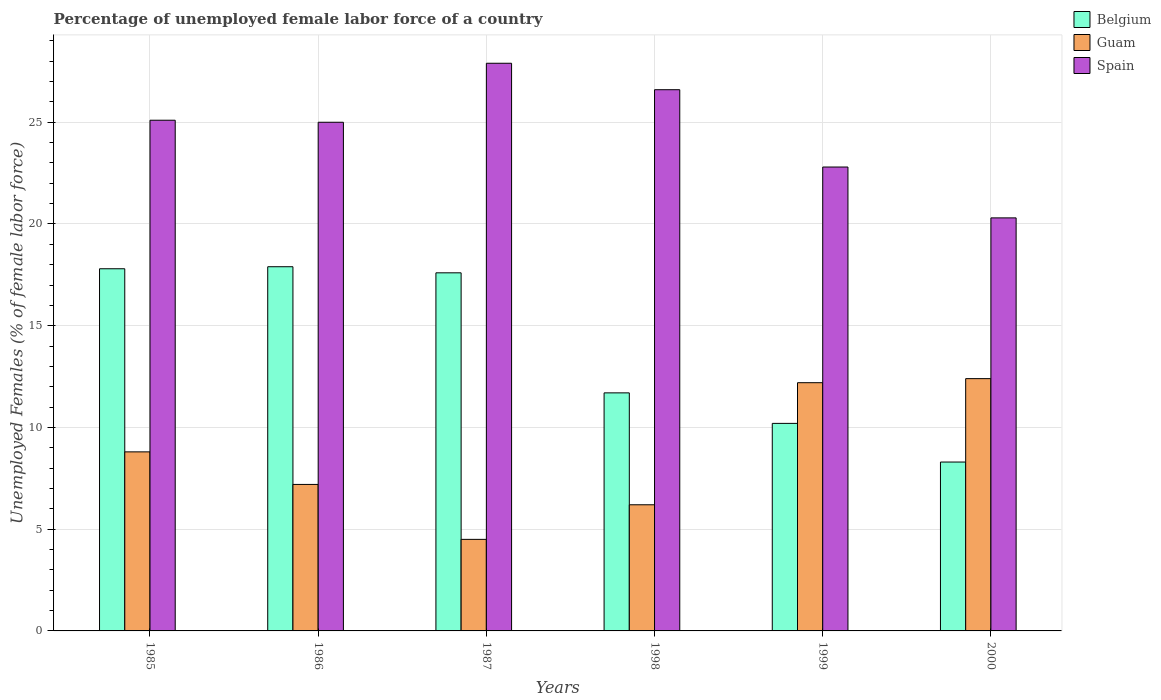How many different coloured bars are there?
Your answer should be compact. 3. What is the percentage of unemployed female labor force in Belgium in 1986?
Offer a very short reply. 17.9. Across all years, what is the maximum percentage of unemployed female labor force in Guam?
Your answer should be compact. 12.4. Across all years, what is the minimum percentage of unemployed female labor force in Belgium?
Give a very brief answer. 8.3. In which year was the percentage of unemployed female labor force in Belgium maximum?
Your answer should be very brief. 1986. What is the total percentage of unemployed female labor force in Belgium in the graph?
Provide a short and direct response. 83.5. What is the difference between the percentage of unemployed female labor force in Belgium in 1998 and that in 2000?
Provide a short and direct response. 3.4. What is the difference between the percentage of unemployed female labor force in Belgium in 1999 and the percentage of unemployed female labor force in Spain in 1985?
Offer a very short reply. -14.9. What is the average percentage of unemployed female labor force in Guam per year?
Offer a very short reply. 8.55. In the year 2000, what is the difference between the percentage of unemployed female labor force in Belgium and percentage of unemployed female labor force in Spain?
Your answer should be very brief. -12. In how many years, is the percentage of unemployed female labor force in Guam greater than 14 %?
Make the answer very short. 0. What is the ratio of the percentage of unemployed female labor force in Guam in 1987 to that in 1999?
Your response must be concise. 0.37. What is the difference between the highest and the second highest percentage of unemployed female labor force in Guam?
Your answer should be very brief. 0.2. What is the difference between the highest and the lowest percentage of unemployed female labor force in Spain?
Ensure brevity in your answer.  7.6. What does the 3rd bar from the left in 1987 represents?
Offer a terse response. Spain. Is it the case that in every year, the sum of the percentage of unemployed female labor force in Guam and percentage of unemployed female labor force in Belgium is greater than the percentage of unemployed female labor force in Spain?
Make the answer very short. No. How many bars are there?
Your answer should be compact. 18. Are all the bars in the graph horizontal?
Make the answer very short. No. How many years are there in the graph?
Make the answer very short. 6. What is the difference between two consecutive major ticks on the Y-axis?
Ensure brevity in your answer.  5. Are the values on the major ticks of Y-axis written in scientific E-notation?
Offer a very short reply. No. Does the graph contain any zero values?
Provide a short and direct response. No. Does the graph contain grids?
Offer a very short reply. Yes. How are the legend labels stacked?
Keep it short and to the point. Vertical. What is the title of the graph?
Keep it short and to the point. Percentage of unemployed female labor force of a country. Does "Nigeria" appear as one of the legend labels in the graph?
Your answer should be very brief. No. What is the label or title of the Y-axis?
Give a very brief answer. Unemployed Females (% of female labor force). What is the Unemployed Females (% of female labor force) of Belgium in 1985?
Keep it short and to the point. 17.8. What is the Unemployed Females (% of female labor force) in Guam in 1985?
Your answer should be very brief. 8.8. What is the Unemployed Females (% of female labor force) in Spain in 1985?
Your answer should be very brief. 25.1. What is the Unemployed Females (% of female labor force) of Belgium in 1986?
Give a very brief answer. 17.9. What is the Unemployed Females (% of female labor force) in Guam in 1986?
Ensure brevity in your answer.  7.2. What is the Unemployed Females (% of female labor force) of Spain in 1986?
Your answer should be compact. 25. What is the Unemployed Females (% of female labor force) of Belgium in 1987?
Keep it short and to the point. 17.6. What is the Unemployed Females (% of female labor force) of Spain in 1987?
Your response must be concise. 27.9. What is the Unemployed Females (% of female labor force) of Belgium in 1998?
Offer a very short reply. 11.7. What is the Unemployed Females (% of female labor force) of Guam in 1998?
Give a very brief answer. 6.2. What is the Unemployed Females (% of female labor force) in Spain in 1998?
Provide a succinct answer. 26.6. What is the Unemployed Females (% of female labor force) in Belgium in 1999?
Provide a short and direct response. 10.2. What is the Unemployed Females (% of female labor force) of Guam in 1999?
Your answer should be compact. 12.2. What is the Unemployed Females (% of female labor force) in Spain in 1999?
Provide a short and direct response. 22.8. What is the Unemployed Females (% of female labor force) in Belgium in 2000?
Keep it short and to the point. 8.3. What is the Unemployed Females (% of female labor force) of Guam in 2000?
Keep it short and to the point. 12.4. What is the Unemployed Females (% of female labor force) of Spain in 2000?
Make the answer very short. 20.3. Across all years, what is the maximum Unemployed Females (% of female labor force) of Belgium?
Offer a terse response. 17.9. Across all years, what is the maximum Unemployed Females (% of female labor force) in Guam?
Offer a very short reply. 12.4. Across all years, what is the maximum Unemployed Females (% of female labor force) of Spain?
Make the answer very short. 27.9. Across all years, what is the minimum Unemployed Females (% of female labor force) in Belgium?
Give a very brief answer. 8.3. Across all years, what is the minimum Unemployed Females (% of female labor force) of Guam?
Give a very brief answer. 4.5. Across all years, what is the minimum Unemployed Females (% of female labor force) of Spain?
Ensure brevity in your answer.  20.3. What is the total Unemployed Females (% of female labor force) in Belgium in the graph?
Ensure brevity in your answer.  83.5. What is the total Unemployed Females (% of female labor force) of Guam in the graph?
Give a very brief answer. 51.3. What is the total Unemployed Females (% of female labor force) of Spain in the graph?
Provide a short and direct response. 147.7. What is the difference between the Unemployed Females (% of female labor force) of Belgium in 1985 and that in 1986?
Provide a short and direct response. -0.1. What is the difference between the Unemployed Females (% of female labor force) in Belgium in 1985 and that in 1998?
Give a very brief answer. 6.1. What is the difference between the Unemployed Females (% of female labor force) in Spain in 1985 and that in 1998?
Provide a succinct answer. -1.5. What is the difference between the Unemployed Females (% of female labor force) of Guam in 1985 and that in 1999?
Provide a succinct answer. -3.4. What is the difference between the Unemployed Females (% of female labor force) of Belgium in 1985 and that in 2000?
Offer a terse response. 9.5. What is the difference between the Unemployed Females (% of female labor force) of Guam in 1986 and that in 1987?
Provide a succinct answer. 2.7. What is the difference between the Unemployed Females (% of female labor force) in Guam in 1986 and that in 1998?
Offer a very short reply. 1. What is the difference between the Unemployed Females (% of female labor force) of Spain in 1986 and that in 1999?
Your answer should be very brief. 2.2. What is the difference between the Unemployed Females (% of female labor force) of Spain in 1986 and that in 2000?
Give a very brief answer. 4.7. What is the difference between the Unemployed Females (% of female labor force) in Spain in 1987 and that in 1998?
Provide a succinct answer. 1.3. What is the difference between the Unemployed Females (% of female labor force) of Belgium in 1987 and that in 1999?
Give a very brief answer. 7.4. What is the difference between the Unemployed Females (% of female labor force) in Spain in 1987 and that in 1999?
Offer a terse response. 5.1. What is the difference between the Unemployed Females (% of female labor force) in Belgium in 1987 and that in 2000?
Offer a very short reply. 9.3. What is the difference between the Unemployed Females (% of female labor force) of Spain in 1987 and that in 2000?
Give a very brief answer. 7.6. What is the difference between the Unemployed Females (% of female labor force) in Guam in 1998 and that in 1999?
Provide a succinct answer. -6. What is the difference between the Unemployed Females (% of female labor force) of Spain in 1998 and that in 1999?
Provide a succinct answer. 3.8. What is the difference between the Unemployed Females (% of female labor force) in Spain in 1998 and that in 2000?
Offer a very short reply. 6.3. What is the difference between the Unemployed Females (% of female labor force) of Belgium in 1999 and that in 2000?
Offer a very short reply. 1.9. What is the difference between the Unemployed Females (% of female labor force) of Belgium in 1985 and the Unemployed Females (% of female labor force) of Spain in 1986?
Give a very brief answer. -7.2. What is the difference between the Unemployed Females (% of female labor force) of Guam in 1985 and the Unemployed Females (% of female labor force) of Spain in 1986?
Give a very brief answer. -16.2. What is the difference between the Unemployed Females (% of female labor force) in Guam in 1985 and the Unemployed Females (% of female labor force) in Spain in 1987?
Provide a succinct answer. -19.1. What is the difference between the Unemployed Females (% of female labor force) of Belgium in 1985 and the Unemployed Females (% of female labor force) of Guam in 1998?
Offer a terse response. 11.6. What is the difference between the Unemployed Females (% of female labor force) in Belgium in 1985 and the Unemployed Females (% of female labor force) in Spain in 1998?
Your response must be concise. -8.8. What is the difference between the Unemployed Females (% of female labor force) in Guam in 1985 and the Unemployed Females (% of female labor force) in Spain in 1998?
Give a very brief answer. -17.8. What is the difference between the Unemployed Females (% of female labor force) in Belgium in 1985 and the Unemployed Females (% of female labor force) in Spain in 2000?
Offer a terse response. -2.5. What is the difference between the Unemployed Females (% of female labor force) of Guam in 1985 and the Unemployed Females (% of female labor force) of Spain in 2000?
Your response must be concise. -11.5. What is the difference between the Unemployed Females (% of female labor force) in Belgium in 1986 and the Unemployed Females (% of female labor force) in Guam in 1987?
Your response must be concise. 13.4. What is the difference between the Unemployed Females (% of female labor force) of Guam in 1986 and the Unemployed Females (% of female labor force) of Spain in 1987?
Provide a succinct answer. -20.7. What is the difference between the Unemployed Females (% of female labor force) in Guam in 1986 and the Unemployed Females (% of female labor force) in Spain in 1998?
Your response must be concise. -19.4. What is the difference between the Unemployed Females (% of female labor force) in Belgium in 1986 and the Unemployed Females (% of female labor force) in Guam in 1999?
Your answer should be compact. 5.7. What is the difference between the Unemployed Females (% of female labor force) of Belgium in 1986 and the Unemployed Females (% of female labor force) of Spain in 1999?
Your response must be concise. -4.9. What is the difference between the Unemployed Females (% of female labor force) in Guam in 1986 and the Unemployed Females (% of female labor force) in Spain in 1999?
Your response must be concise. -15.6. What is the difference between the Unemployed Females (% of female labor force) in Belgium in 1987 and the Unemployed Females (% of female labor force) in Guam in 1998?
Ensure brevity in your answer.  11.4. What is the difference between the Unemployed Females (% of female labor force) in Guam in 1987 and the Unemployed Females (% of female labor force) in Spain in 1998?
Your response must be concise. -22.1. What is the difference between the Unemployed Females (% of female labor force) in Belgium in 1987 and the Unemployed Females (% of female labor force) in Guam in 1999?
Offer a very short reply. 5.4. What is the difference between the Unemployed Females (% of female labor force) of Guam in 1987 and the Unemployed Females (% of female labor force) of Spain in 1999?
Provide a succinct answer. -18.3. What is the difference between the Unemployed Females (% of female labor force) of Belgium in 1987 and the Unemployed Females (% of female labor force) of Spain in 2000?
Ensure brevity in your answer.  -2.7. What is the difference between the Unemployed Females (% of female labor force) of Guam in 1987 and the Unemployed Females (% of female labor force) of Spain in 2000?
Your answer should be compact. -15.8. What is the difference between the Unemployed Females (% of female labor force) of Belgium in 1998 and the Unemployed Females (% of female labor force) of Guam in 1999?
Provide a short and direct response. -0.5. What is the difference between the Unemployed Females (% of female labor force) in Guam in 1998 and the Unemployed Females (% of female labor force) in Spain in 1999?
Offer a very short reply. -16.6. What is the difference between the Unemployed Females (% of female labor force) of Belgium in 1998 and the Unemployed Females (% of female labor force) of Guam in 2000?
Your answer should be compact. -0.7. What is the difference between the Unemployed Females (% of female labor force) in Guam in 1998 and the Unemployed Females (% of female labor force) in Spain in 2000?
Your response must be concise. -14.1. What is the difference between the Unemployed Females (% of female labor force) in Belgium in 1999 and the Unemployed Females (% of female labor force) in Spain in 2000?
Your response must be concise. -10.1. What is the difference between the Unemployed Females (% of female labor force) of Guam in 1999 and the Unemployed Females (% of female labor force) of Spain in 2000?
Keep it short and to the point. -8.1. What is the average Unemployed Females (% of female labor force) of Belgium per year?
Your response must be concise. 13.92. What is the average Unemployed Females (% of female labor force) of Guam per year?
Give a very brief answer. 8.55. What is the average Unemployed Females (% of female labor force) of Spain per year?
Offer a terse response. 24.62. In the year 1985, what is the difference between the Unemployed Females (% of female labor force) of Guam and Unemployed Females (% of female labor force) of Spain?
Give a very brief answer. -16.3. In the year 1986, what is the difference between the Unemployed Females (% of female labor force) in Belgium and Unemployed Females (% of female labor force) in Guam?
Give a very brief answer. 10.7. In the year 1986, what is the difference between the Unemployed Females (% of female labor force) of Belgium and Unemployed Females (% of female labor force) of Spain?
Give a very brief answer. -7.1. In the year 1986, what is the difference between the Unemployed Females (% of female labor force) of Guam and Unemployed Females (% of female labor force) of Spain?
Offer a terse response. -17.8. In the year 1987, what is the difference between the Unemployed Females (% of female labor force) in Belgium and Unemployed Females (% of female labor force) in Guam?
Offer a terse response. 13.1. In the year 1987, what is the difference between the Unemployed Females (% of female labor force) of Belgium and Unemployed Females (% of female labor force) of Spain?
Your response must be concise. -10.3. In the year 1987, what is the difference between the Unemployed Females (% of female labor force) of Guam and Unemployed Females (% of female labor force) of Spain?
Your response must be concise. -23.4. In the year 1998, what is the difference between the Unemployed Females (% of female labor force) in Belgium and Unemployed Females (% of female labor force) in Spain?
Make the answer very short. -14.9. In the year 1998, what is the difference between the Unemployed Females (% of female labor force) of Guam and Unemployed Females (% of female labor force) of Spain?
Make the answer very short. -20.4. In the year 1999, what is the difference between the Unemployed Females (% of female labor force) of Belgium and Unemployed Females (% of female labor force) of Guam?
Keep it short and to the point. -2. In the year 1999, what is the difference between the Unemployed Females (% of female labor force) in Belgium and Unemployed Females (% of female labor force) in Spain?
Provide a succinct answer. -12.6. In the year 2000, what is the difference between the Unemployed Females (% of female labor force) in Guam and Unemployed Females (% of female labor force) in Spain?
Your answer should be very brief. -7.9. What is the ratio of the Unemployed Females (% of female labor force) in Guam in 1985 to that in 1986?
Offer a very short reply. 1.22. What is the ratio of the Unemployed Females (% of female labor force) in Belgium in 1985 to that in 1987?
Make the answer very short. 1.01. What is the ratio of the Unemployed Females (% of female labor force) of Guam in 1985 to that in 1987?
Keep it short and to the point. 1.96. What is the ratio of the Unemployed Females (% of female labor force) in Spain in 1985 to that in 1987?
Provide a succinct answer. 0.9. What is the ratio of the Unemployed Females (% of female labor force) of Belgium in 1985 to that in 1998?
Provide a short and direct response. 1.52. What is the ratio of the Unemployed Females (% of female labor force) in Guam in 1985 to that in 1998?
Your answer should be compact. 1.42. What is the ratio of the Unemployed Females (% of female labor force) of Spain in 1985 to that in 1998?
Provide a short and direct response. 0.94. What is the ratio of the Unemployed Females (% of female labor force) in Belgium in 1985 to that in 1999?
Ensure brevity in your answer.  1.75. What is the ratio of the Unemployed Females (% of female labor force) in Guam in 1985 to that in 1999?
Give a very brief answer. 0.72. What is the ratio of the Unemployed Females (% of female labor force) in Spain in 1985 to that in 1999?
Make the answer very short. 1.1. What is the ratio of the Unemployed Females (% of female labor force) in Belgium in 1985 to that in 2000?
Your response must be concise. 2.14. What is the ratio of the Unemployed Females (% of female labor force) of Guam in 1985 to that in 2000?
Provide a short and direct response. 0.71. What is the ratio of the Unemployed Females (% of female labor force) of Spain in 1985 to that in 2000?
Offer a very short reply. 1.24. What is the ratio of the Unemployed Females (% of female labor force) in Belgium in 1986 to that in 1987?
Offer a very short reply. 1.02. What is the ratio of the Unemployed Females (% of female labor force) of Guam in 1986 to that in 1987?
Your response must be concise. 1.6. What is the ratio of the Unemployed Females (% of female labor force) of Spain in 1986 to that in 1987?
Keep it short and to the point. 0.9. What is the ratio of the Unemployed Females (% of female labor force) in Belgium in 1986 to that in 1998?
Give a very brief answer. 1.53. What is the ratio of the Unemployed Females (% of female labor force) in Guam in 1986 to that in 1998?
Your response must be concise. 1.16. What is the ratio of the Unemployed Females (% of female labor force) in Spain in 1986 to that in 1998?
Your response must be concise. 0.94. What is the ratio of the Unemployed Females (% of female labor force) in Belgium in 1986 to that in 1999?
Provide a succinct answer. 1.75. What is the ratio of the Unemployed Females (% of female labor force) of Guam in 1986 to that in 1999?
Offer a terse response. 0.59. What is the ratio of the Unemployed Females (% of female labor force) of Spain in 1986 to that in 1999?
Your response must be concise. 1.1. What is the ratio of the Unemployed Females (% of female labor force) in Belgium in 1986 to that in 2000?
Ensure brevity in your answer.  2.16. What is the ratio of the Unemployed Females (% of female labor force) of Guam in 1986 to that in 2000?
Provide a short and direct response. 0.58. What is the ratio of the Unemployed Females (% of female labor force) of Spain in 1986 to that in 2000?
Your answer should be very brief. 1.23. What is the ratio of the Unemployed Females (% of female labor force) of Belgium in 1987 to that in 1998?
Provide a short and direct response. 1.5. What is the ratio of the Unemployed Females (% of female labor force) in Guam in 1987 to that in 1998?
Your answer should be compact. 0.73. What is the ratio of the Unemployed Females (% of female labor force) of Spain in 1987 to that in 1998?
Your answer should be compact. 1.05. What is the ratio of the Unemployed Females (% of female labor force) in Belgium in 1987 to that in 1999?
Provide a succinct answer. 1.73. What is the ratio of the Unemployed Females (% of female labor force) of Guam in 1987 to that in 1999?
Provide a short and direct response. 0.37. What is the ratio of the Unemployed Females (% of female labor force) of Spain in 1987 to that in 1999?
Make the answer very short. 1.22. What is the ratio of the Unemployed Females (% of female labor force) of Belgium in 1987 to that in 2000?
Give a very brief answer. 2.12. What is the ratio of the Unemployed Females (% of female labor force) of Guam in 1987 to that in 2000?
Offer a very short reply. 0.36. What is the ratio of the Unemployed Females (% of female labor force) of Spain in 1987 to that in 2000?
Your response must be concise. 1.37. What is the ratio of the Unemployed Females (% of female labor force) in Belgium in 1998 to that in 1999?
Provide a succinct answer. 1.15. What is the ratio of the Unemployed Females (% of female labor force) in Guam in 1998 to that in 1999?
Keep it short and to the point. 0.51. What is the ratio of the Unemployed Females (% of female labor force) in Belgium in 1998 to that in 2000?
Provide a short and direct response. 1.41. What is the ratio of the Unemployed Females (% of female labor force) of Guam in 1998 to that in 2000?
Offer a terse response. 0.5. What is the ratio of the Unemployed Females (% of female labor force) of Spain in 1998 to that in 2000?
Keep it short and to the point. 1.31. What is the ratio of the Unemployed Females (% of female labor force) in Belgium in 1999 to that in 2000?
Make the answer very short. 1.23. What is the ratio of the Unemployed Females (% of female labor force) in Guam in 1999 to that in 2000?
Give a very brief answer. 0.98. What is the ratio of the Unemployed Females (% of female labor force) in Spain in 1999 to that in 2000?
Make the answer very short. 1.12. What is the difference between the highest and the second highest Unemployed Females (% of female labor force) of Belgium?
Your answer should be compact. 0.1. What is the difference between the highest and the second highest Unemployed Females (% of female labor force) of Spain?
Offer a very short reply. 1.3. What is the difference between the highest and the lowest Unemployed Females (% of female labor force) of Guam?
Offer a very short reply. 7.9. 